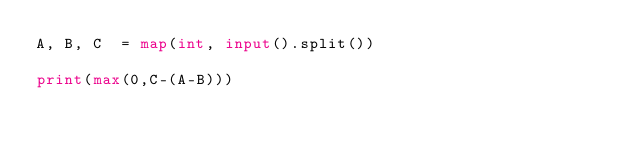<code> <loc_0><loc_0><loc_500><loc_500><_Python_>A, B, C  = map(int, input().split())

print(max(0,C-(A-B)))</code> 